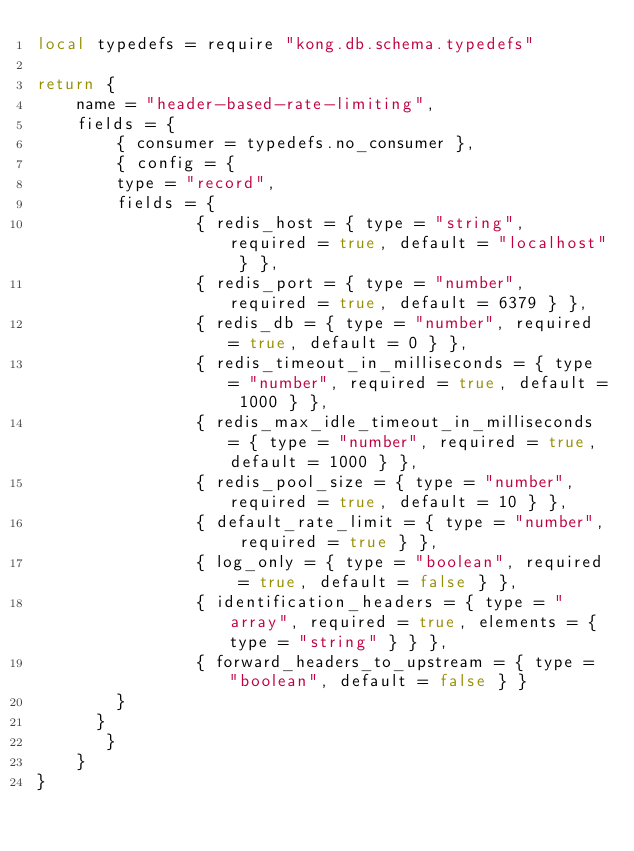Convert code to text. <code><loc_0><loc_0><loc_500><loc_500><_Lua_>local typedefs = require "kong.db.schema.typedefs"

return {
    name = "header-based-rate-limiting",
    fields = {
    	{ consumer = typedefs.no_consumer },
        { config = { 
	    type = "record",
	    fields = {
                { redis_host = { type = "string", required = true, default = "localhost" } },
                { redis_port = { type = "number", required = true, default = 6379 } },
                { redis_db = { type = "number", required = true, default = 0 } },
                { redis_timeout_in_milliseconds = { type = "number", required = true, default = 1000 } },
                { redis_max_idle_timeout_in_milliseconds = { type = "number", required = true, default = 1000 } },
                { redis_pool_size = { type = "number", required = true, default = 10 } },
                { default_rate_limit = { type = "number", required = true } },
                { log_only = { type = "boolean", required = true, default = false } },
                { identification_headers = { type = "array", required = true, elements = { type = "string" } } },
                { forward_headers_to_upstream = { type = "boolean", default = false } }
	    }
	  }
       }
    }
}
</code> 